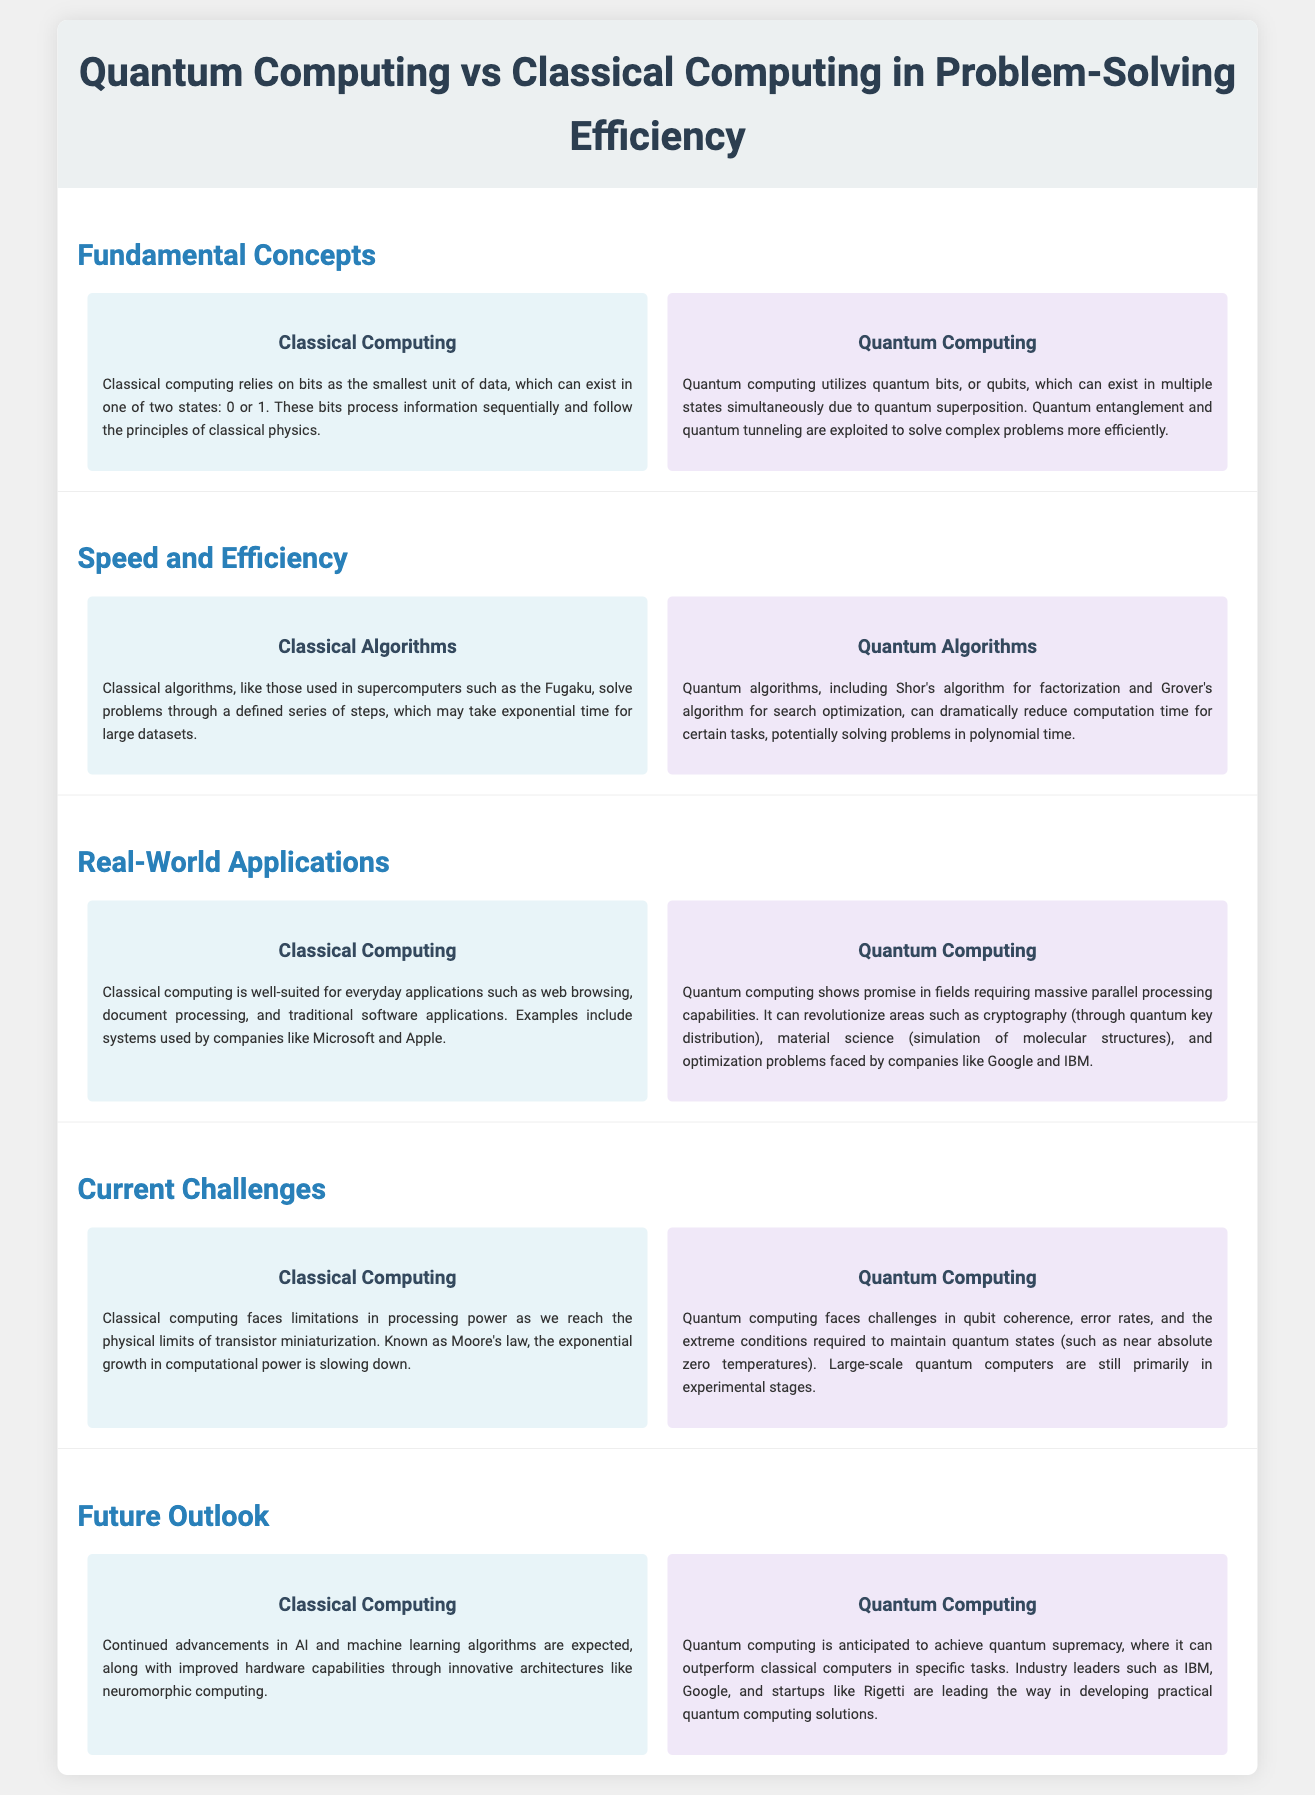What is the smallest unit of data in Classical Computing? The smallest unit of data in Classical Computing is a bit, which can exist in one of two states: 0 or 1.
Answer: bit What does Quantum Computing utilize to process information? Quantum Computing utilizes quantum bits or qubits, which can exist in multiple states simultaneously due to quantum superposition.
Answer: qubits What is an example of a classical algorithm mentioned in the document? An example of a classical algorithm is the one used in supercomputers such as the Fugaku, which solves problems through a defined series of steps.
Answer: Fugaku Which quantum algorithm is used for search optimization? Grover's algorithm is mentioned as a quantum algorithm for search optimization.
Answer: Grover's algorithm What real-world application is suited for Classical Computing? Classical Computing is well-suited for applications such as web browsing and document processing.
Answer: web browsing What is a key challenge for Quantum Computing mentioned? A key challenge for Quantum Computing is qubit coherence and error rates.
Answer: qubit coherence What future prospect is anticipated for Quantum Computing? Quantum Computing is anticipated to achieve quantum supremacy, outperforming classical computers in specific tasks.
Answer: quantum supremacy What is one limitation classical computing faces? Classical computing faces limitations in processing power due to the physical limits of transistor miniaturization.
Answer: transistor miniaturization What company is associated with developing practical quantum computing solutions? IBM is one of the industry leaders mentioned in developing practical quantum computing solutions.
Answer: IBM 